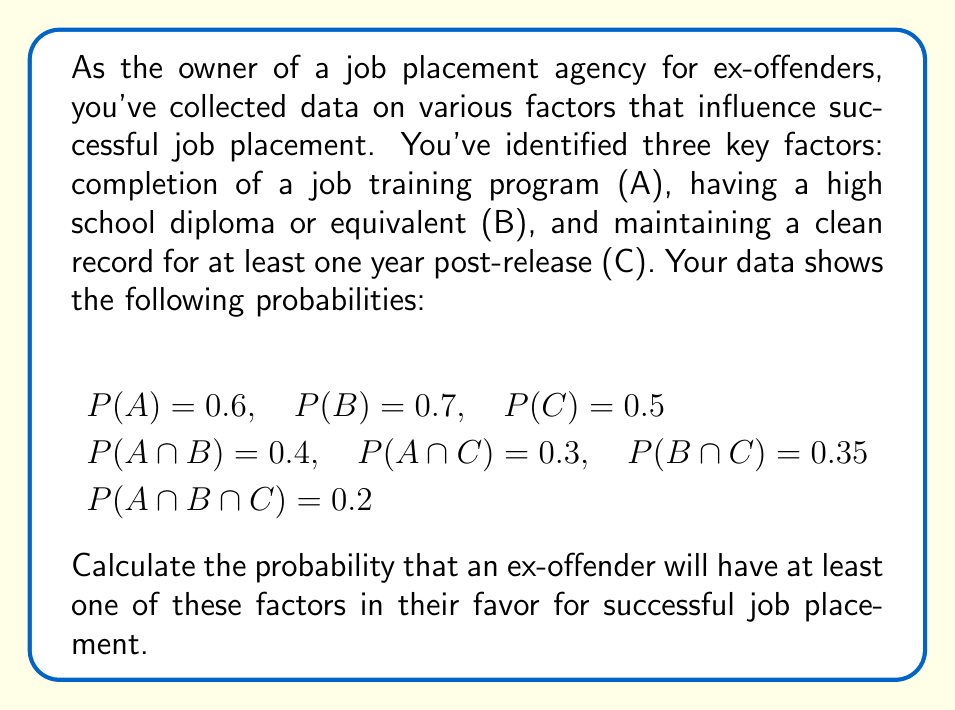Help me with this question. To solve this problem, we need to use the Inclusion-Exclusion Principle for three sets. The probability of at least one event occurring is equal to the sum of the probabilities of each event, minus the probabilities of their intersections, plus the probability of all three occurring together.

Let's follow these steps:

1) The formula for the probability of at least one event occurring is:

   $$P(A \cup B \cup C) = P(A) + P(B) + P(C) - P(A \cap B) - P(A \cap C) - P(B \cap C) + P(A \cap B \cap C)$$

2) We're given all these probabilities, so let's substitute them:

   $$P(A \cup B \cup C) = 0.6 + 0.7 + 0.5 - 0.4 - 0.3 - 0.35 + 0.2$$

3) Now, let's calculate:

   $$P(A \cup B \cup C) = 1.8 - 1.05 + 0.2$$

4) Simplify:

   $$P(A \cup B \cup C) = 0.95$$

Therefore, the probability that an ex-offender will have at least one of these factors in their favor for successful job placement is 0.95 or 95%.
Answer: 0.95 